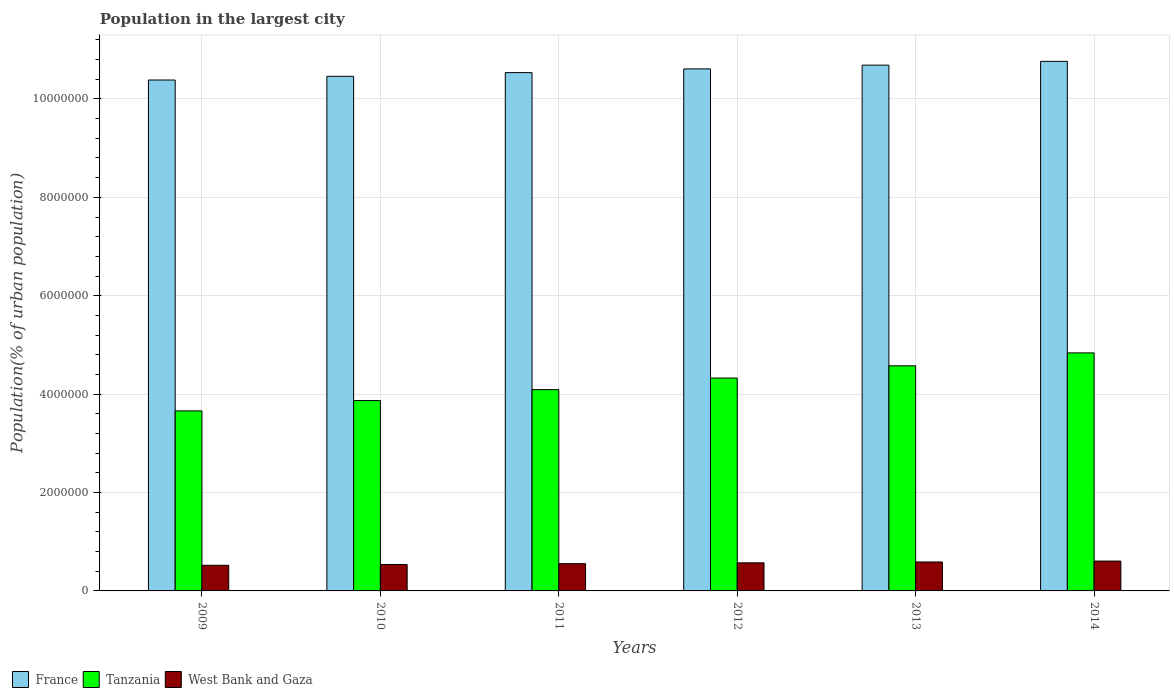Are the number of bars on each tick of the X-axis equal?
Provide a succinct answer. Yes. How many bars are there on the 6th tick from the left?
Keep it short and to the point. 3. How many bars are there on the 2nd tick from the right?
Provide a succinct answer. 3. What is the label of the 1st group of bars from the left?
Provide a short and direct response. 2009. What is the population in the largest city in France in 2013?
Offer a very short reply. 1.07e+07. Across all years, what is the maximum population in the largest city in West Bank and Gaza?
Ensure brevity in your answer.  6.07e+05. Across all years, what is the minimum population in the largest city in West Bank and Gaza?
Ensure brevity in your answer.  5.21e+05. In which year was the population in the largest city in Tanzania minimum?
Your answer should be very brief. 2009. What is the total population in the largest city in West Bank and Gaza in the graph?
Provide a short and direct response. 3.38e+06. What is the difference between the population in the largest city in Tanzania in 2009 and that in 2014?
Give a very brief answer. -1.18e+06. What is the difference between the population in the largest city in France in 2011 and the population in the largest city in Tanzania in 2014?
Your response must be concise. 5.70e+06. What is the average population in the largest city in France per year?
Provide a short and direct response. 1.06e+07. In the year 2012, what is the difference between the population in the largest city in Tanzania and population in the largest city in West Bank and Gaza?
Offer a terse response. 3.76e+06. What is the ratio of the population in the largest city in West Bank and Gaza in 2009 to that in 2010?
Provide a short and direct response. 0.97. Is the population in the largest city in West Bank and Gaza in 2012 less than that in 2014?
Keep it short and to the point. Yes. What is the difference between the highest and the second highest population in the largest city in West Bank and Gaza?
Make the answer very short. 1.81e+04. What is the difference between the highest and the lowest population in the largest city in West Bank and Gaza?
Keep it short and to the point. 8.54e+04. In how many years, is the population in the largest city in France greater than the average population in the largest city in France taken over all years?
Offer a very short reply. 3. What does the 3rd bar from the right in 2011 represents?
Give a very brief answer. France. How many bars are there?
Your answer should be compact. 18. Are all the bars in the graph horizontal?
Make the answer very short. No. How many years are there in the graph?
Ensure brevity in your answer.  6. Are the values on the major ticks of Y-axis written in scientific E-notation?
Offer a terse response. No. Where does the legend appear in the graph?
Provide a succinct answer. Bottom left. What is the title of the graph?
Your answer should be compact. Population in the largest city. Does "Jamaica" appear as one of the legend labels in the graph?
Keep it short and to the point. No. What is the label or title of the Y-axis?
Your answer should be very brief. Population(% of urban population). What is the Population(% of urban population) in France in 2009?
Your response must be concise. 1.04e+07. What is the Population(% of urban population) in Tanzania in 2009?
Keep it short and to the point. 3.66e+06. What is the Population(% of urban population) of West Bank and Gaza in 2009?
Your answer should be very brief. 5.21e+05. What is the Population(% of urban population) of France in 2010?
Give a very brief answer. 1.05e+07. What is the Population(% of urban population) in Tanzania in 2010?
Offer a terse response. 3.87e+06. What is the Population(% of urban population) of West Bank and Gaza in 2010?
Ensure brevity in your answer.  5.37e+05. What is the Population(% of urban population) in France in 2011?
Give a very brief answer. 1.05e+07. What is the Population(% of urban population) in Tanzania in 2011?
Provide a short and direct response. 4.09e+06. What is the Population(% of urban population) in West Bank and Gaza in 2011?
Make the answer very short. 5.54e+05. What is the Population(% of urban population) of France in 2012?
Offer a very short reply. 1.06e+07. What is the Population(% of urban population) of Tanzania in 2012?
Keep it short and to the point. 4.33e+06. What is the Population(% of urban population) of West Bank and Gaza in 2012?
Ensure brevity in your answer.  5.71e+05. What is the Population(% of urban population) in France in 2013?
Make the answer very short. 1.07e+07. What is the Population(% of urban population) of Tanzania in 2013?
Your answer should be very brief. 4.58e+06. What is the Population(% of urban population) of West Bank and Gaza in 2013?
Provide a short and direct response. 5.88e+05. What is the Population(% of urban population) of France in 2014?
Offer a very short reply. 1.08e+07. What is the Population(% of urban population) in Tanzania in 2014?
Ensure brevity in your answer.  4.84e+06. What is the Population(% of urban population) of West Bank and Gaza in 2014?
Ensure brevity in your answer.  6.07e+05. Across all years, what is the maximum Population(% of urban population) in France?
Offer a terse response. 1.08e+07. Across all years, what is the maximum Population(% of urban population) of Tanzania?
Offer a very short reply. 4.84e+06. Across all years, what is the maximum Population(% of urban population) in West Bank and Gaza?
Provide a succinct answer. 6.07e+05. Across all years, what is the minimum Population(% of urban population) of France?
Keep it short and to the point. 1.04e+07. Across all years, what is the minimum Population(% of urban population) of Tanzania?
Give a very brief answer. 3.66e+06. Across all years, what is the minimum Population(% of urban population) in West Bank and Gaza?
Give a very brief answer. 5.21e+05. What is the total Population(% of urban population) in France in the graph?
Ensure brevity in your answer.  6.34e+07. What is the total Population(% of urban population) of Tanzania in the graph?
Offer a very short reply. 2.54e+07. What is the total Population(% of urban population) of West Bank and Gaza in the graph?
Offer a very short reply. 3.38e+06. What is the difference between the Population(% of urban population) of France in 2009 and that in 2010?
Provide a succinct answer. -7.47e+04. What is the difference between the Population(% of urban population) in Tanzania in 2009 and that in 2010?
Provide a succinct answer. -2.10e+05. What is the difference between the Population(% of urban population) of West Bank and Gaza in 2009 and that in 2010?
Ensure brevity in your answer.  -1.61e+04. What is the difference between the Population(% of urban population) in France in 2009 and that in 2011?
Provide a succinct answer. -1.50e+05. What is the difference between the Population(% of urban population) of Tanzania in 2009 and that in 2011?
Ensure brevity in your answer.  -4.33e+05. What is the difference between the Population(% of urban population) of West Bank and Gaza in 2009 and that in 2011?
Your answer should be very brief. -3.26e+04. What is the difference between the Population(% of urban population) in France in 2009 and that in 2012?
Provide a succinct answer. -2.26e+05. What is the difference between the Population(% of urban population) in Tanzania in 2009 and that in 2012?
Give a very brief answer. -6.68e+05. What is the difference between the Population(% of urban population) in West Bank and Gaza in 2009 and that in 2012?
Make the answer very short. -4.97e+04. What is the difference between the Population(% of urban population) of France in 2009 and that in 2013?
Offer a very short reply. -3.02e+05. What is the difference between the Population(% of urban population) of Tanzania in 2009 and that in 2013?
Offer a very short reply. -9.16e+05. What is the difference between the Population(% of urban population) in West Bank and Gaza in 2009 and that in 2013?
Offer a very short reply. -6.73e+04. What is the difference between the Population(% of urban population) in France in 2009 and that in 2014?
Give a very brief answer. -3.79e+05. What is the difference between the Population(% of urban population) of Tanzania in 2009 and that in 2014?
Provide a short and direct response. -1.18e+06. What is the difference between the Population(% of urban population) of West Bank and Gaza in 2009 and that in 2014?
Make the answer very short. -8.54e+04. What is the difference between the Population(% of urban population) in France in 2010 and that in 2011?
Your answer should be compact. -7.53e+04. What is the difference between the Population(% of urban population) of Tanzania in 2010 and that in 2011?
Provide a short and direct response. -2.22e+05. What is the difference between the Population(% of urban population) in West Bank and Gaza in 2010 and that in 2011?
Ensure brevity in your answer.  -1.66e+04. What is the difference between the Population(% of urban population) of France in 2010 and that in 2012?
Make the answer very short. -1.51e+05. What is the difference between the Population(% of urban population) in Tanzania in 2010 and that in 2012?
Give a very brief answer. -4.58e+05. What is the difference between the Population(% of urban population) in West Bank and Gaza in 2010 and that in 2012?
Provide a succinct answer. -3.37e+04. What is the difference between the Population(% of urban population) of France in 2010 and that in 2013?
Offer a very short reply. -2.27e+05. What is the difference between the Population(% of urban population) in Tanzania in 2010 and that in 2013?
Keep it short and to the point. -7.06e+05. What is the difference between the Population(% of urban population) of West Bank and Gaza in 2010 and that in 2013?
Give a very brief answer. -5.12e+04. What is the difference between the Population(% of urban population) in France in 2010 and that in 2014?
Your answer should be very brief. -3.04e+05. What is the difference between the Population(% of urban population) of Tanzania in 2010 and that in 2014?
Provide a succinct answer. -9.68e+05. What is the difference between the Population(% of urban population) of West Bank and Gaza in 2010 and that in 2014?
Your answer should be very brief. -6.94e+04. What is the difference between the Population(% of urban population) in France in 2011 and that in 2012?
Ensure brevity in your answer.  -7.58e+04. What is the difference between the Population(% of urban population) in Tanzania in 2011 and that in 2012?
Make the answer very short. -2.35e+05. What is the difference between the Population(% of urban population) of West Bank and Gaza in 2011 and that in 2012?
Give a very brief answer. -1.71e+04. What is the difference between the Population(% of urban population) of France in 2011 and that in 2013?
Provide a succinct answer. -1.52e+05. What is the difference between the Population(% of urban population) of Tanzania in 2011 and that in 2013?
Your answer should be compact. -4.84e+05. What is the difference between the Population(% of urban population) of West Bank and Gaza in 2011 and that in 2013?
Your answer should be compact. -3.47e+04. What is the difference between the Population(% of urban population) in France in 2011 and that in 2014?
Make the answer very short. -2.29e+05. What is the difference between the Population(% of urban population) in Tanzania in 2011 and that in 2014?
Your answer should be very brief. -7.46e+05. What is the difference between the Population(% of urban population) of West Bank and Gaza in 2011 and that in 2014?
Give a very brief answer. -5.28e+04. What is the difference between the Population(% of urban population) of France in 2012 and that in 2013?
Ensure brevity in your answer.  -7.63e+04. What is the difference between the Population(% of urban population) of Tanzania in 2012 and that in 2013?
Provide a short and direct response. -2.48e+05. What is the difference between the Population(% of urban population) in West Bank and Gaza in 2012 and that in 2013?
Provide a succinct answer. -1.76e+04. What is the difference between the Population(% of urban population) of France in 2012 and that in 2014?
Your answer should be compact. -1.53e+05. What is the difference between the Population(% of urban population) of Tanzania in 2012 and that in 2014?
Offer a terse response. -5.11e+05. What is the difference between the Population(% of urban population) of West Bank and Gaza in 2012 and that in 2014?
Keep it short and to the point. -3.57e+04. What is the difference between the Population(% of urban population) of France in 2013 and that in 2014?
Offer a very short reply. -7.69e+04. What is the difference between the Population(% of urban population) in Tanzania in 2013 and that in 2014?
Offer a terse response. -2.62e+05. What is the difference between the Population(% of urban population) of West Bank and Gaza in 2013 and that in 2014?
Keep it short and to the point. -1.81e+04. What is the difference between the Population(% of urban population) in France in 2009 and the Population(% of urban population) in Tanzania in 2010?
Your response must be concise. 6.52e+06. What is the difference between the Population(% of urban population) in France in 2009 and the Population(% of urban population) in West Bank and Gaza in 2010?
Your answer should be compact. 9.85e+06. What is the difference between the Population(% of urban population) in Tanzania in 2009 and the Population(% of urban population) in West Bank and Gaza in 2010?
Offer a terse response. 3.12e+06. What is the difference between the Population(% of urban population) of France in 2009 and the Population(% of urban population) of Tanzania in 2011?
Offer a very short reply. 6.29e+06. What is the difference between the Population(% of urban population) of France in 2009 and the Population(% of urban population) of West Bank and Gaza in 2011?
Offer a very short reply. 9.83e+06. What is the difference between the Population(% of urban population) in Tanzania in 2009 and the Population(% of urban population) in West Bank and Gaza in 2011?
Offer a terse response. 3.11e+06. What is the difference between the Population(% of urban population) in France in 2009 and the Population(% of urban population) in Tanzania in 2012?
Your response must be concise. 6.06e+06. What is the difference between the Population(% of urban population) in France in 2009 and the Population(% of urban population) in West Bank and Gaza in 2012?
Make the answer very short. 9.81e+06. What is the difference between the Population(% of urban population) in Tanzania in 2009 and the Population(% of urban population) in West Bank and Gaza in 2012?
Give a very brief answer. 3.09e+06. What is the difference between the Population(% of urban population) in France in 2009 and the Population(% of urban population) in Tanzania in 2013?
Your answer should be compact. 5.81e+06. What is the difference between the Population(% of urban population) in France in 2009 and the Population(% of urban population) in West Bank and Gaza in 2013?
Offer a very short reply. 9.80e+06. What is the difference between the Population(% of urban population) of Tanzania in 2009 and the Population(% of urban population) of West Bank and Gaza in 2013?
Ensure brevity in your answer.  3.07e+06. What is the difference between the Population(% of urban population) of France in 2009 and the Population(% of urban population) of Tanzania in 2014?
Provide a short and direct response. 5.55e+06. What is the difference between the Population(% of urban population) in France in 2009 and the Population(% of urban population) in West Bank and Gaza in 2014?
Your answer should be compact. 9.78e+06. What is the difference between the Population(% of urban population) of Tanzania in 2009 and the Population(% of urban population) of West Bank and Gaza in 2014?
Your answer should be very brief. 3.05e+06. What is the difference between the Population(% of urban population) in France in 2010 and the Population(% of urban population) in Tanzania in 2011?
Your answer should be compact. 6.37e+06. What is the difference between the Population(% of urban population) in France in 2010 and the Population(% of urban population) in West Bank and Gaza in 2011?
Your answer should be very brief. 9.91e+06. What is the difference between the Population(% of urban population) in Tanzania in 2010 and the Population(% of urban population) in West Bank and Gaza in 2011?
Provide a short and direct response. 3.32e+06. What is the difference between the Population(% of urban population) of France in 2010 and the Population(% of urban population) of Tanzania in 2012?
Your answer should be very brief. 6.13e+06. What is the difference between the Population(% of urban population) of France in 2010 and the Population(% of urban population) of West Bank and Gaza in 2012?
Your answer should be compact. 9.89e+06. What is the difference between the Population(% of urban population) in Tanzania in 2010 and the Population(% of urban population) in West Bank and Gaza in 2012?
Offer a very short reply. 3.30e+06. What is the difference between the Population(% of urban population) in France in 2010 and the Population(% of urban population) in Tanzania in 2013?
Offer a terse response. 5.88e+06. What is the difference between the Population(% of urban population) of France in 2010 and the Population(% of urban population) of West Bank and Gaza in 2013?
Offer a very short reply. 9.87e+06. What is the difference between the Population(% of urban population) in Tanzania in 2010 and the Population(% of urban population) in West Bank and Gaza in 2013?
Provide a succinct answer. 3.28e+06. What is the difference between the Population(% of urban population) in France in 2010 and the Population(% of urban population) in Tanzania in 2014?
Provide a short and direct response. 5.62e+06. What is the difference between the Population(% of urban population) of France in 2010 and the Population(% of urban population) of West Bank and Gaza in 2014?
Provide a short and direct response. 9.85e+06. What is the difference between the Population(% of urban population) of Tanzania in 2010 and the Population(% of urban population) of West Bank and Gaza in 2014?
Give a very brief answer. 3.26e+06. What is the difference between the Population(% of urban population) in France in 2011 and the Population(% of urban population) in Tanzania in 2012?
Ensure brevity in your answer.  6.21e+06. What is the difference between the Population(% of urban population) in France in 2011 and the Population(% of urban population) in West Bank and Gaza in 2012?
Your answer should be very brief. 9.96e+06. What is the difference between the Population(% of urban population) of Tanzania in 2011 and the Population(% of urban population) of West Bank and Gaza in 2012?
Offer a terse response. 3.52e+06. What is the difference between the Population(% of urban population) in France in 2011 and the Population(% of urban population) in Tanzania in 2013?
Make the answer very short. 5.96e+06. What is the difference between the Population(% of urban population) of France in 2011 and the Population(% of urban population) of West Bank and Gaza in 2013?
Make the answer very short. 9.95e+06. What is the difference between the Population(% of urban population) in Tanzania in 2011 and the Population(% of urban population) in West Bank and Gaza in 2013?
Your answer should be compact. 3.50e+06. What is the difference between the Population(% of urban population) of France in 2011 and the Population(% of urban population) of Tanzania in 2014?
Keep it short and to the point. 5.70e+06. What is the difference between the Population(% of urban population) in France in 2011 and the Population(% of urban population) in West Bank and Gaza in 2014?
Keep it short and to the point. 9.93e+06. What is the difference between the Population(% of urban population) in Tanzania in 2011 and the Population(% of urban population) in West Bank and Gaza in 2014?
Offer a very short reply. 3.49e+06. What is the difference between the Population(% of urban population) of France in 2012 and the Population(% of urban population) of Tanzania in 2013?
Make the answer very short. 6.04e+06. What is the difference between the Population(% of urban population) in France in 2012 and the Population(% of urban population) in West Bank and Gaza in 2013?
Give a very brief answer. 1.00e+07. What is the difference between the Population(% of urban population) of Tanzania in 2012 and the Population(% of urban population) of West Bank and Gaza in 2013?
Provide a succinct answer. 3.74e+06. What is the difference between the Population(% of urban population) in France in 2012 and the Population(% of urban population) in Tanzania in 2014?
Make the answer very short. 5.77e+06. What is the difference between the Population(% of urban population) in France in 2012 and the Population(% of urban population) in West Bank and Gaza in 2014?
Provide a short and direct response. 1.00e+07. What is the difference between the Population(% of urban population) in Tanzania in 2012 and the Population(% of urban population) in West Bank and Gaza in 2014?
Offer a terse response. 3.72e+06. What is the difference between the Population(% of urban population) of France in 2013 and the Population(% of urban population) of Tanzania in 2014?
Your response must be concise. 5.85e+06. What is the difference between the Population(% of urban population) in France in 2013 and the Population(% of urban population) in West Bank and Gaza in 2014?
Ensure brevity in your answer.  1.01e+07. What is the difference between the Population(% of urban population) in Tanzania in 2013 and the Population(% of urban population) in West Bank and Gaza in 2014?
Your answer should be very brief. 3.97e+06. What is the average Population(% of urban population) of France per year?
Keep it short and to the point. 1.06e+07. What is the average Population(% of urban population) of Tanzania per year?
Your response must be concise. 4.23e+06. What is the average Population(% of urban population) of West Bank and Gaza per year?
Provide a succinct answer. 5.63e+05. In the year 2009, what is the difference between the Population(% of urban population) of France and Population(% of urban population) of Tanzania?
Ensure brevity in your answer.  6.73e+06. In the year 2009, what is the difference between the Population(% of urban population) of France and Population(% of urban population) of West Bank and Gaza?
Provide a short and direct response. 9.86e+06. In the year 2009, what is the difference between the Population(% of urban population) in Tanzania and Population(% of urban population) in West Bank and Gaza?
Make the answer very short. 3.14e+06. In the year 2010, what is the difference between the Population(% of urban population) of France and Population(% of urban population) of Tanzania?
Your answer should be very brief. 6.59e+06. In the year 2010, what is the difference between the Population(% of urban population) of France and Population(% of urban population) of West Bank and Gaza?
Make the answer very short. 9.92e+06. In the year 2010, what is the difference between the Population(% of urban population) in Tanzania and Population(% of urban population) in West Bank and Gaza?
Offer a terse response. 3.33e+06. In the year 2011, what is the difference between the Population(% of urban population) of France and Population(% of urban population) of Tanzania?
Offer a terse response. 6.44e+06. In the year 2011, what is the difference between the Population(% of urban population) in France and Population(% of urban population) in West Bank and Gaza?
Your answer should be very brief. 9.98e+06. In the year 2011, what is the difference between the Population(% of urban population) in Tanzania and Population(% of urban population) in West Bank and Gaza?
Your answer should be compact. 3.54e+06. In the year 2012, what is the difference between the Population(% of urban population) of France and Population(% of urban population) of Tanzania?
Ensure brevity in your answer.  6.28e+06. In the year 2012, what is the difference between the Population(% of urban population) in France and Population(% of urban population) in West Bank and Gaza?
Give a very brief answer. 1.00e+07. In the year 2012, what is the difference between the Population(% of urban population) of Tanzania and Population(% of urban population) of West Bank and Gaza?
Provide a succinct answer. 3.76e+06. In the year 2013, what is the difference between the Population(% of urban population) in France and Population(% of urban population) in Tanzania?
Your answer should be compact. 6.11e+06. In the year 2013, what is the difference between the Population(% of urban population) in France and Population(% of urban population) in West Bank and Gaza?
Ensure brevity in your answer.  1.01e+07. In the year 2013, what is the difference between the Population(% of urban population) of Tanzania and Population(% of urban population) of West Bank and Gaza?
Offer a very short reply. 3.99e+06. In the year 2014, what is the difference between the Population(% of urban population) in France and Population(% of urban population) in Tanzania?
Your answer should be compact. 5.93e+06. In the year 2014, what is the difference between the Population(% of urban population) in France and Population(% of urban population) in West Bank and Gaza?
Your answer should be compact. 1.02e+07. In the year 2014, what is the difference between the Population(% of urban population) of Tanzania and Population(% of urban population) of West Bank and Gaza?
Provide a short and direct response. 4.23e+06. What is the ratio of the Population(% of urban population) in France in 2009 to that in 2010?
Offer a very short reply. 0.99. What is the ratio of the Population(% of urban population) of Tanzania in 2009 to that in 2010?
Offer a terse response. 0.95. What is the ratio of the Population(% of urban population) of West Bank and Gaza in 2009 to that in 2010?
Offer a terse response. 0.97. What is the ratio of the Population(% of urban population) in France in 2009 to that in 2011?
Offer a very short reply. 0.99. What is the ratio of the Population(% of urban population) of Tanzania in 2009 to that in 2011?
Give a very brief answer. 0.89. What is the ratio of the Population(% of urban population) in West Bank and Gaza in 2009 to that in 2011?
Offer a terse response. 0.94. What is the ratio of the Population(% of urban population) in France in 2009 to that in 2012?
Keep it short and to the point. 0.98. What is the ratio of the Population(% of urban population) in Tanzania in 2009 to that in 2012?
Ensure brevity in your answer.  0.85. What is the ratio of the Population(% of urban population) of West Bank and Gaza in 2009 to that in 2012?
Keep it short and to the point. 0.91. What is the ratio of the Population(% of urban population) in France in 2009 to that in 2013?
Offer a very short reply. 0.97. What is the ratio of the Population(% of urban population) in Tanzania in 2009 to that in 2013?
Provide a succinct answer. 0.8. What is the ratio of the Population(% of urban population) in West Bank and Gaza in 2009 to that in 2013?
Offer a very short reply. 0.89. What is the ratio of the Population(% of urban population) of France in 2009 to that in 2014?
Your answer should be very brief. 0.96. What is the ratio of the Population(% of urban population) of Tanzania in 2009 to that in 2014?
Keep it short and to the point. 0.76. What is the ratio of the Population(% of urban population) in West Bank and Gaza in 2009 to that in 2014?
Your answer should be compact. 0.86. What is the ratio of the Population(% of urban population) of France in 2010 to that in 2011?
Give a very brief answer. 0.99. What is the ratio of the Population(% of urban population) in Tanzania in 2010 to that in 2011?
Your answer should be compact. 0.95. What is the ratio of the Population(% of urban population) of West Bank and Gaza in 2010 to that in 2011?
Offer a very short reply. 0.97. What is the ratio of the Population(% of urban population) in France in 2010 to that in 2012?
Offer a very short reply. 0.99. What is the ratio of the Population(% of urban population) in Tanzania in 2010 to that in 2012?
Ensure brevity in your answer.  0.89. What is the ratio of the Population(% of urban population) in West Bank and Gaza in 2010 to that in 2012?
Provide a succinct answer. 0.94. What is the ratio of the Population(% of urban population) in France in 2010 to that in 2013?
Keep it short and to the point. 0.98. What is the ratio of the Population(% of urban population) of Tanzania in 2010 to that in 2013?
Offer a terse response. 0.85. What is the ratio of the Population(% of urban population) of West Bank and Gaza in 2010 to that in 2013?
Provide a short and direct response. 0.91. What is the ratio of the Population(% of urban population) of France in 2010 to that in 2014?
Your answer should be very brief. 0.97. What is the ratio of the Population(% of urban population) of Tanzania in 2010 to that in 2014?
Keep it short and to the point. 0.8. What is the ratio of the Population(% of urban population) of West Bank and Gaza in 2010 to that in 2014?
Give a very brief answer. 0.89. What is the ratio of the Population(% of urban population) in France in 2011 to that in 2012?
Provide a succinct answer. 0.99. What is the ratio of the Population(% of urban population) of Tanzania in 2011 to that in 2012?
Offer a terse response. 0.95. What is the ratio of the Population(% of urban population) of West Bank and Gaza in 2011 to that in 2012?
Your answer should be compact. 0.97. What is the ratio of the Population(% of urban population) in France in 2011 to that in 2013?
Your response must be concise. 0.99. What is the ratio of the Population(% of urban population) of Tanzania in 2011 to that in 2013?
Keep it short and to the point. 0.89. What is the ratio of the Population(% of urban population) in West Bank and Gaza in 2011 to that in 2013?
Offer a very short reply. 0.94. What is the ratio of the Population(% of urban population) of France in 2011 to that in 2014?
Your answer should be compact. 0.98. What is the ratio of the Population(% of urban population) in Tanzania in 2011 to that in 2014?
Provide a short and direct response. 0.85. What is the ratio of the Population(% of urban population) of France in 2012 to that in 2013?
Provide a succinct answer. 0.99. What is the ratio of the Population(% of urban population) of Tanzania in 2012 to that in 2013?
Provide a short and direct response. 0.95. What is the ratio of the Population(% of urban population) of West Bank and Gaza in 2012 to that in 2013?
Offer a terse response. 0.97. What is the ratio of the Population(% of urban population) of France in 2012 to that in 2014?
Provide a succinct answer. 0.99. What is the ratio of the Population(% of urban population) in Tanzania in 2012 to that in 2014?
Your response must be concise. 0.89. What is the ratio of the Population(% of urban population) in West Bank and Gaza in 2012 to that in 2014?
Make the answer very short. 0.94. What is the ratio of the Population(% of urban population) of France in 2013 to that in 2014?
Your response must be concise. 0.99. What is the ratio of the Population(% of urban population) of Tanzania in 2013 to that in 2014?
Your response must be concise. 0.95. What is the ratio of the Population(% of urban population) of West Bank and Gaza in 2013 to that in 2014?
Offer a terse response. 0.97. What is the difference between the highest and the second highest Population(% of urban population) of France?
Your response must be concise. 7.69e+04. What is the difference between the highest and the second highest Population(% of urban population) of Tanzania?
Your response must be concise. 2.62e+05. What is the difference between the highest and the second highest Population(% of urban population) of West Bank and Gaza?
Provide a succinct answer. 1.81e+04. What is the difference between the highest and the lowest Population(% of urban population) of France?
Offer a terse response. 3.79e+05. What is the difference between the highest and the lowest Population(% of urban population) in Tanzania?
Make the answer very short. 1.18e+06. What is the difference between the highest and the lowest Population(% of urban population) of West Bank and Gaza?
Your answer should be very brief. 8.54e+04. 